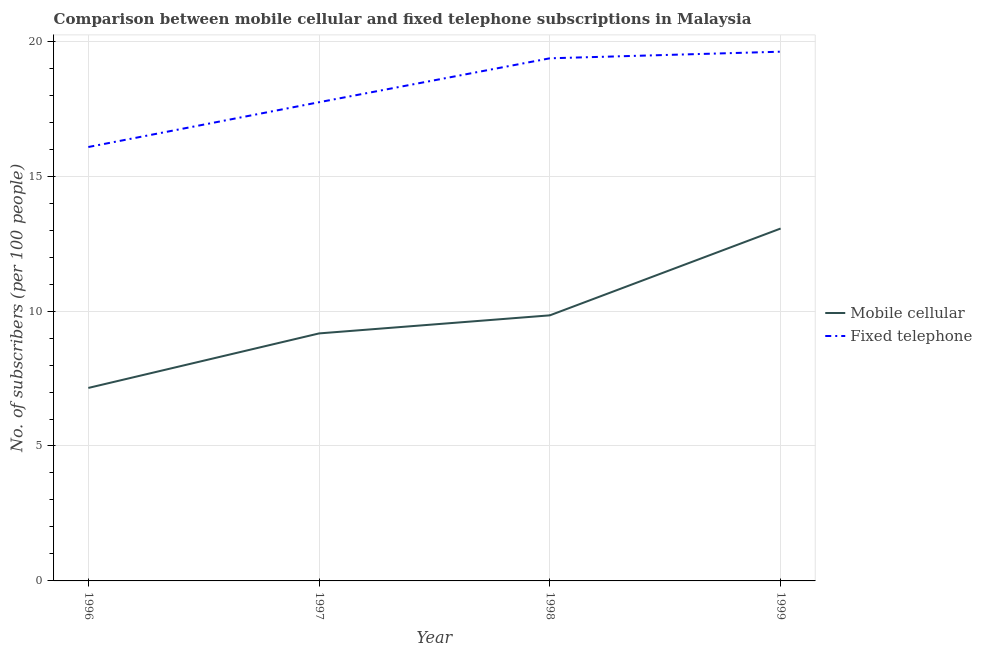Does the line corresponding to number of mobile cellular subscribers intersect with the line corresponding to number of fixed telephone subscribers?
Your answer should be very brief. No. What is the number of mobile cellular subscribers in 1996?
Your answer should be very brief. 7.15. Across all years, what is the maximum number of mobile cellular subscribers?
Your answer should be compact. 13.06. Across all years, what is the minimum number of fixed telephone subscribers?
Your answer should be compact. 16.08. In which year was the number of fixed telephone subscribers maximum?
Make the answer very short. 1999. In which year was the number of mobile cellular subscribers minimum?
Keep it short and to the point. 1996. What is the total number of mobile cellular subscribers in the graph?
Offer a terse response. 39.22. What is the difference between the number of mobile cellular subscribers in 1996 and that in 1998?
Your answer should be very brief. -2.69. What is the difference between the number of mobile cellular subscribers in 1998 and the number of fixed telephone subscribers in 1996?
Provide a succinct answer. -6.24. What is the average number of fixed telephone subscribers per year?
Ensure brevity in your answer.  18.2. In the year 1998, what is the difference between the number of mobile cellular subscribers and number of fixed telephone subscribers?
Your response must be concise. -9.53. In how many years, is the number of fixed telephone subscribers greater than 19?
Give a very brief answer. 2. What is the ratio of the number of fixed telephone subscribers in 1997 to that in 1998?
Ensure brevity in your answer.  0.92. Is the number of mobile cellular subscribers in 1996 less than that in 1997?
Your answer should be very brief. Yes. What is the difference between the highest and the second highest number of mobile cellular subscribers?
Your answer should be compact. 3.22. What is the difference between the highest and the lowest number of mobile cellular subscribers?
Offer a terse response. 5.91. In how many years, is the number of fixed telephone subscribers greater than the average number of fixed telephone subscribers taken over all years?
Offer a terse response. 2. Does the number of fixed telephone subscribers monotonically increase over the years?
Keep it short and to the point. Yes. How many years are there in the graph?
Offer a very short reply. 4. What is the difference between two consecutive major ticks on the Y-axis?
Your answer should be compact. 5. Does the graph contain any zero values?
Your response must be concise. No. Where does the legend appear in the graph?
Your response must be concise. Center right. How are the legend labels stacked?
Ensure brevity in your answer.  Vertical. What is the title of the graph?
Provide a short and direct response. Comparison between mobile cellular and fixed telephone subscriptions in Malaysia. What is the label or title of the Y-axis?
Give a very brief answer. No. of subscribers (per 100 people). What is the No. of subscribers (per 100 people) in Mobile cellular in 1996?
Give a very brief answer. 7.15. What is the No. of subscribers (per 100 people) in Fixed telephone in 1996?
Keep it short and to the point. 16.08. What is the No. of subscribers (per 100 people) in Mobile cellular in 1997?
Your response must be concise. 9.17. What is the No. of subscribers (per 100 people) of Fixed telephone in 1997?
Offer a very short reply. 17.74. What is the No. of subscribers (per 100 people) of Mobile cellular in 1998?
Provide a succinct answer. 9.84. What is the No. of subscribers (per 100 people) in Fixed telephone in 1998?
Ensure brevity in your answer.  19.37. What is the No. of subscribers (per 100 people) in Mobile cellular in 1999?
Offer a terse response. 13.06. What is the No. of subscribers (per 100 people) of Fixed telephone in 1999?
Ensure brevity in your answer.  19.61. Across all years, what is the maximum No. of subscribers (per 100 people) of Mobile cellular?
Your answer should be compact. 13.06. Across all years, what is the maximum No. of subscribers (per 100 people) of Fixed telephone?
Ensure brevity in your answer.  19.61. Across all years, what is the minimum No. of subscribers (per 100 people) of Mobile cellular?
Provide a succinct answer. 7.15. Across all years, what is the minimum No. of subscribers (per 100 people) in Fixed telephone?
Your response must be concise. 16.08. What is the total No. of subscribers (per 100 people) in Mobile cellular in the graph?
Provide a succinct answer. 39.22. What is the total No. of subscribers (per 100 people) of Fixed telephone in the graph?
Keep it short and to the point. 72.8. What is the difference between the No. of subscribers (per 100 people) of Mobile cellular in 1996 and that in 1997?
Provide a succinct answer. -2.02. What is the difference between the No. of subscribers (per 100 people) in Fixed telephone in 1996 and that in 1997?
Give a very brief answer. -1.66. What is the difference between the No. of subscribers (per 100 people) of Mobile cellular in 1996 and that in 1998?
Provide a short and direct response. -2.69. What is the difference between the No. of subscribers (per 100 people) of Fixed telephone in 1996 and that in 1998?
Provide a succinct answer. -3.29. What is the difference between the No. of subscribers (per 100 people) of Mobile cellular in 1996 and that in 1999?
Make the answer very short. -5.91. What is the difference between the No. of subscribers (per 100 people) in Fixed telephone in 1996 and that in 1999?
Your answer should be compact. -3.53. What is the difference between the No. of subscribers (per 100 people) in Mobile cellular in 1997 and that in 1998?
Make the answer very short. -0.67. What is the difference between the No. of subscribers (per 100 people) of Fixed telephone in 1997 and that in 1998?
Keep it short and to the point. -1.63. What is the difference between the No. of subscribers (per 100 people) of Mobile cellular in 1997 and that in 1999?
Provide a short and direct response. -3.89. What is the difference between the No. of subscribers (per 100 people) of Fixed telephone in 1997 and that in 1999?
Keep it short and to the point. -1.87. What is the difference between the No. of subscribers (per 100 people) of Mobile cellular in 1998 and that in 1999?
Keep it short and to the point. -3.22. What is the difference between the No. of subscribers (per 100 people) of Fixed telephone in 1998 and that in 1999?
Your response must be concise. -0.24. What is the difference between the No. of subscribers (per 100 people) in Mobile cellular in 1996 and the No. of subscribers (per 100 people) in Fixed telephone in 1997?
Make the answer very short. -10.59. What is the difference between the No. of subscribers (per 100 people) in Mobile cellular in 1996 and the No. of subscribers (per 100 people) in Fixed telephone in 1998?
Keep it short and to the point. -12.22. What is the difference between the No. of subscribers (per 100 people) of Mobile cellular in 1996 and the No. of subscribers (per 100 people) of Fixed telephone in 1999?
Make the answer very short. -12.46. What is the difference between the No. of subscribers (per 100 people) in Mobile cellular in 1997 and the No. of subscribers (per 100 people) in Fixed telephone in 1998?
Keep it short and to the point. -10.19. What is the difference between the No. of subscribers (per 100 people) of Mobile cellular in 1997 and the No. of subscribers (per 100 people) of Fixed telephone in 1999?
Your answer should be very brief. -10.44. What is the difference between the No. of subscribers (per 100 people) in Mobile cellular in 1998 and the No. of subscribers (per 100 people) in Fixed telephone in 1999?
Make the answer very short. -9.77. What is the average No. of subscribers (per 100 people) in Mobile cellular per year?
Your response must be concise. 9.81. What is the average No. of subscribers (per 100 people) of Fixed telephone per year?
Make the answer very short. 18.2. In the year 1996, what is the difference between the No. of subscribers (per 100 people) in Mobile cellular and No. of subscribers (per 100 people) in Fixed telephone?
Give a very brief answer. -8.93. In the year 1997, what is the difference between the No. of subscribers (per 100 people) in Mobile cellular and No. of subscribers (per 100 people) in Fixed telephone?
Your answer should be compact. -8.57. In the year 1998, what is the difference between the No. of subscribers (per 100 people) in Mobile cellular and No. of subscribers (per 100 people) in Fixed telephone?
Your answer should be very brief. -9.53. In the year 1999, what is the difference between the No. of subscribers (per 100 people) in Mobile cellular and No. of subscribers (per 100 people) in Fixed telephone?
Ensure brevity in your answer.  -6.55. What is the ratio of the No. of subscribers (per 100 people) in Mobile cellular in 1996 to that in 1997?
Ensure brevity in your answer.  0.78. What is the ratio of the No. of subscribers (per 100 people) in Fixed telephone in 1996 to that in 1997?
Keep it short and to the point. 0.91. What is the ratio of the No. of subscribers (per 100 people) in Mobile cellular in 1996 to that in 1998?
Provide a succinct answer. 0.73. What is the ratio of the No. of subscribers (per 100 people) of Fixed telephone in 1996 to that in 1998?
Give a very brief answer. 0.83. What is the ratio of the No. of subscribers (per 100 people) of Mobile cellular in 1996 to that in 1999?
Provide a succinct answer. 0.55. What is the ratio of the No. of subscribers (per 100 people) in Fixed telephone in 1996 to that in 1999?
Your answer should be very brief. 0.82. What is the ratio of the No. of subscribers (per 100 people) in Mobile cellular in 1997 to that in 1998?
Provide a succinct answer. 0.93. What is the ratio of the No. of subscribers (per 100 people) of Fixed telephone in 1997 to that in 1998?
Keep it short and to the point. 0.92. What is the ratio of the No. of subscribers (per 100 people) in Mobile cellular in 1997 to that in 1999?
Your answer should be very brief. 0.7. What is the ratio of the No. of subscribers (per 100 people) of Fixed telephone in 1997 to that in 1999?
Ensure brevity in your answer.  0.9. What is the ratio of the No. of subscribers (per 100 people) of Mobile cellular in 1998 to that in 1999?
Provide a succinct answer. 0.75. What is the ratio of the No. of subscribers (per 100 people) in Fixed telephone in 1998 to that in 1999?
Ensure brevity in your answer.  0.99. What is the difference between the highest and the second highest No. of subscribers (per 100 people) in Mobile cellular?
Give a very brief answer. 3.22. What is the difference between the highest and the second highest No. of subscribers (per 100 people) in Fixed telephone?
Your response must be concise. 0.24. What is the difference between the highest and the lowest No. of subscribers (per 100 people) of Mobile cellular?
Keep it short and to the point. 5.91. What is the difference between the highest and the lowest No. of subscribers (per 100 people) of Fixed telephone?
Offer a terse response. 3.53. 